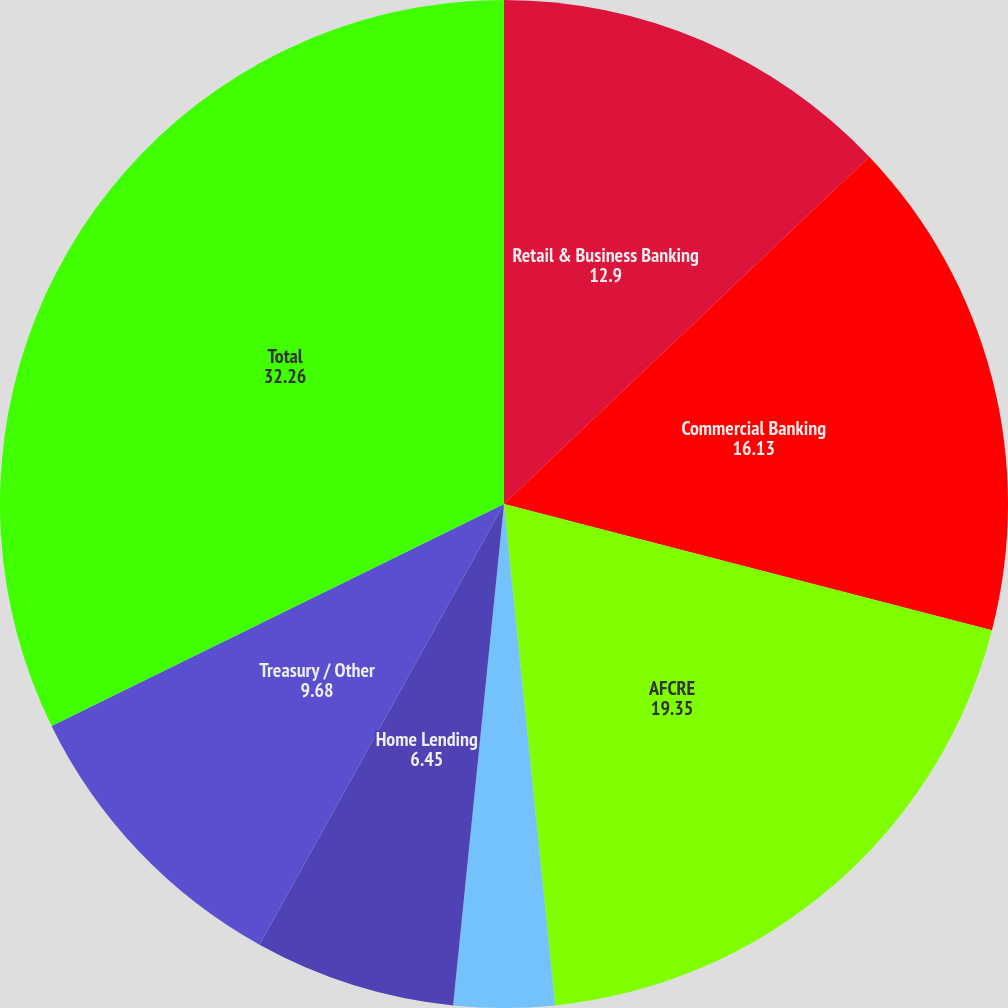Convert chart. <chart><loc_0><loc_0><loc_500><loc_500><pie_chart><fcel>(dollar amounts in thousands)<fcel>Retail & Business Banking<fcel>Commercial Banking<fcel>AFCRE<fcel>RBHPCG<fcel>Home Lending<fcel>Treasury / Other<fcel>Total<nl><fcel>0.0%<fcel>12.9%<fcel>16.13%<fcel>19.35%<fcel>3.23%<fcel>6.45%<fcel>9.68%<fcel>32.26%<nl></chart> 